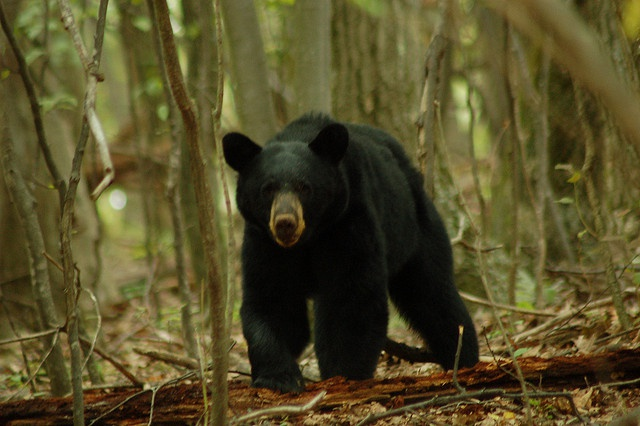Describe the objects in this image and their specific colors. I can see a bear in darkgreen, black, and maroon tones in this image. 